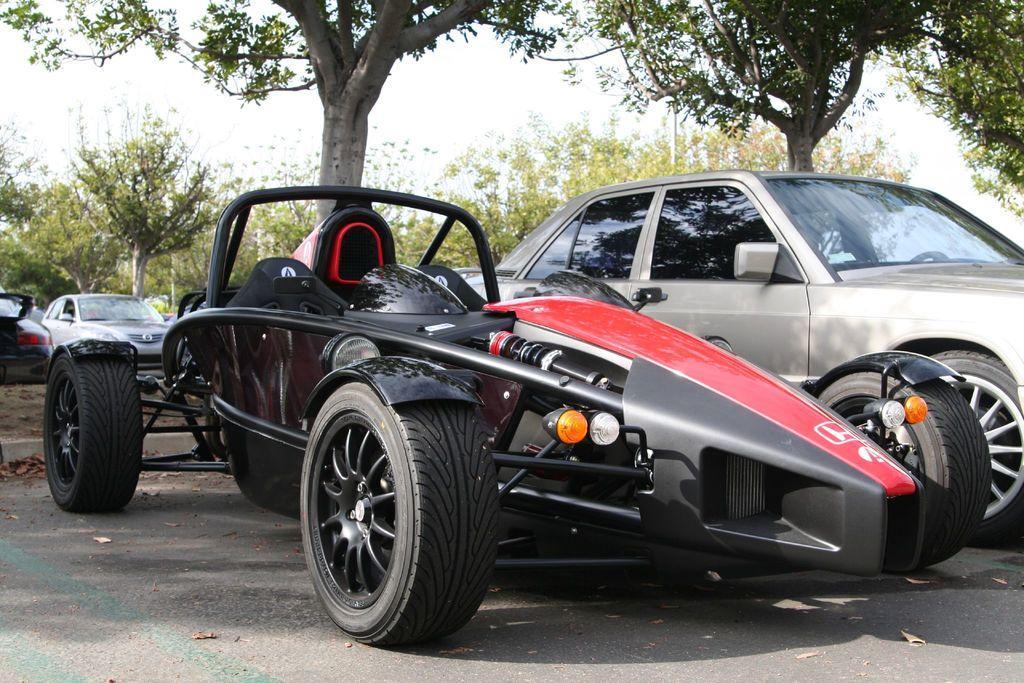Can you describe this image briefly? In this picture I can observe two cars. One of them is looking like F1 racing car. In the background there are trees and sky. 